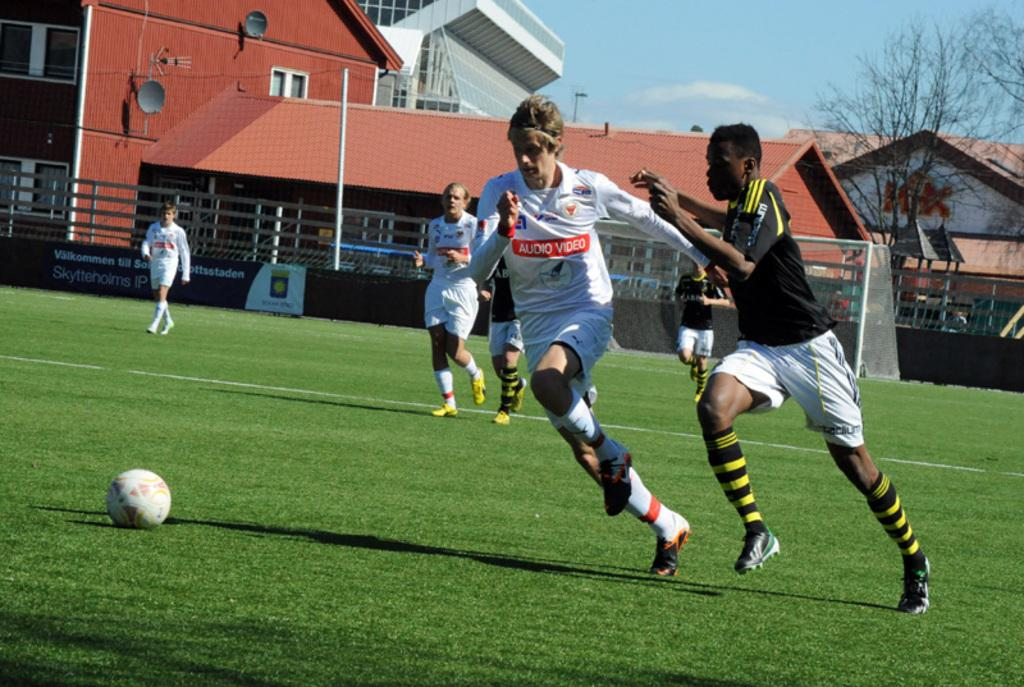<image>
Give a short and clear explanation of the subsequent image. a person with audio video on their shirt playing some soccer 